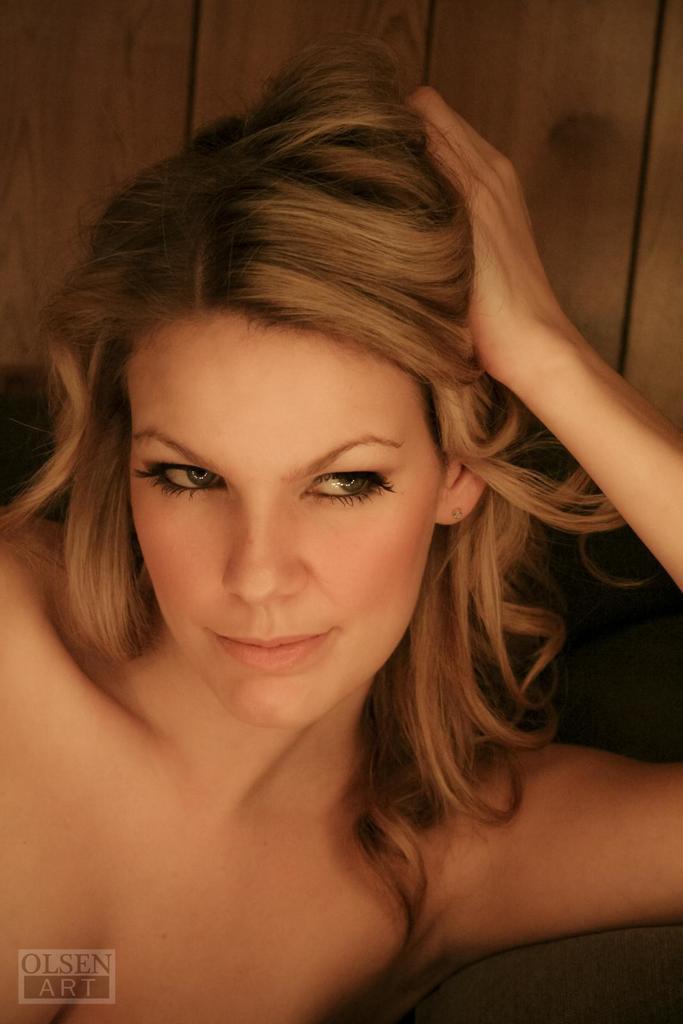In one or two sentences, can you explain what this image depicts? In this image there is a woman smiling. 